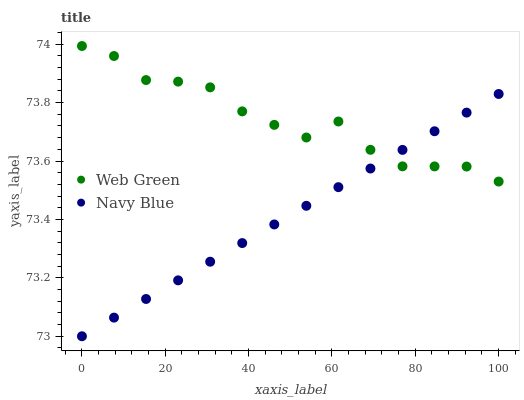Does Navy Blue have the minimum area under the curve?
Answer yes or no. Yes. Does Web Green have the maximum area under the curve?
Answer yes or no. Yes. Does Web Green have the minimum area under the curve?
Answer yes or no. No. Is Navy Blue the smoothest?
Answer yes or no. Yes. Is Web Green the roughest?
Answer yes or no. Yes. Is Web Green the smoothest?
Answer yes or no. No. Does Navy Blue have the lowest value?
Answer yes or no. Yes. Does Web Green have the lowest value?
Answer yes or no. No. Does Web Green have the highest value?
Answer yes or no. Yes. Does Navy Blue intersect Web Green?
Answer yes or no. Yes. Is Navy Blue less than Web Green?
Answer yes or no. No. Is Navy Blue greater than Web Green?
Answer yes or no. No. 